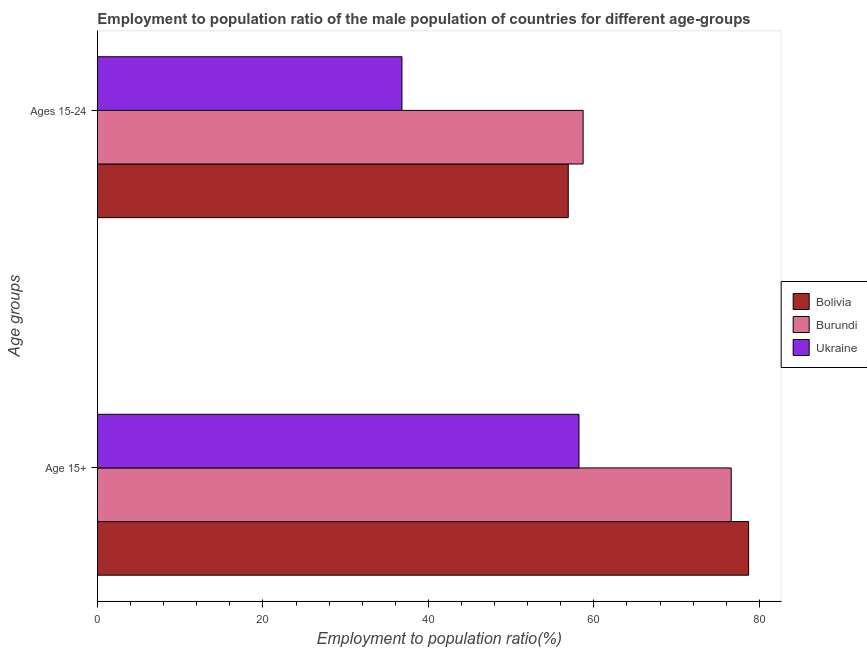How many different coloured bars are there?
Make the answer very short. 3. Are the number of bars on each tick of the Y-axis equal?
Provide a short and direct response. Yes. How many bars are there on the 1st tick from the top?
Offer a terse response. 3. What is the label of the 1st group of bars from the top?
Offer a very short reply. Ages 15-24. What is the employment to population ratio(age 15+) in Ukraine?
Offer a terse response. 58.2. Across all countries, what is the maximum employment to population ratio(age 15-24)?
Provide a short and direct response. 58.7. Across all countries, what is the minimum employment to population ratio(age 15-24)?
Your answer should be very brief. 36.8. In which country was the employment to population ratio(age 15-24) maximum?
Give a very brief answer. Burundi. In which country was the employment to population ratio(age 15-24) minimum?
Ensure brevity in your answer.  Ukraine. What is the total employment to population ratio(age 15+) in the graph?
Provide a succinct answer. 213.5. What is the difference between the employment to population ratio(age 15-24) in Ukraine and that in Burundi?
Offer a terse response. -21.9. What is the difference between the employment to population ratio(age 15-24) in Burundi and the employment to population ratio(age 15+) in Ukraine?
Make the answer very short. 0.5. What is the average employment to population ratio(age 15+) per country?
Make the answer very short. 71.17. What is the difference between the employment to population ratio(age 15-24) and employment to population ratio(age 15+) in Burundi?
Offer a terse response. -17.9. What is the ratio of the employment to population ratio(age 15-24) in Burundi to that in Bolivia?
Your answer should be compact. 1.03. Is the employment to population ratio(age 15-24) in Burundi less than that in Ukraine?
Give a very brief answer. No. What does the 1st bar from the top in Age 15+ represents?
Make the answer very short. Ukraine. What does the 2nd bar from the bottom in Age 15+ represents?
Ensure brevity in your answer.  Burundi. How many bars are there?
Offer a very short reply. 6. Are all the bars in the graph horizontal?
Make the answer very short. Yes. How many countries are there in the graph?
Give a very brief answer. 3. What is the difference between two consecutive major ticks on the X-axis?
Keep it short and to the point. 20. How many legend labels are there?
Provide a succinct answer. 3. How are the legend labels stacked?
Keep it short and to the point. Vertical. What is the title of the graph?
Keep it short and to the point. Employment to population ratio of the male population of countries for different age-groups. Does "Mauritius" appear as one of the legend labels in the graph?
Your answer should be compact. No. What is the label or title of the X-axis?
Keep it short and to the point. Employment to population ratio(%). What is the label or title of the Y-axis?
Offer a terse response. Age groups. What is the Employment to population ratio(%) of Bolivia in Age 15+?
Keep it short and to the point. 78.7. What is the Employment to population ratio(%) in Burundi in Age 15+?
Your answer should be very brief. 76.6. What is the Employment to population ratio(%) of Ukraine in Age 15+?
Ensure brevity in your answer.  58.2. What is the Employment to population ratio(%) in Bolivia in Ages 15-24?
Offer a very short reply. 56.9. What is the Employment to population ratio(%) in Burundi in Ages 15-24?
Offer a very short reply. 58.7. What is the Employment to population ratio(%) in Ukraine in Ages 15-24?
Your answer should be compact. 36.8. Across all Age groups, what is the maximum Employment to population ratio(%) in Bolivia?
Give a very brief answer. 78.7. Across all Age groups, what is the maximum Employment to population ratio(%) in Burundi?
Ensure brevity in your answer.  76.6. Across all Age groups, what is the maximum Employment to population ratio(%) in Ukraine?
Make the answer very short. 58.2. Across all Age groups, what is the minimum Employment to population ratio(%) of Bolivia?
Make the answer very short. 56.9. Across all Age groups, what is the minimum Employment to population ratio(%) in Burundi?
Provide a short and direct response. 58.7. Across all Age groups, what is the minimum Employment to population ratio(%) in Ukraine?
Offer a very short reply. 36.8. What is the total Employment to population ratio(%) of Bolivia in the graph?
Your response must be concise. 135.6. What is the total Employment to population ratio(%) in Burundi in the graph?
Provide a succinct answer. 135.3. What is the difference between the Employment to population ratio(%) of Bolivia in Age 15+ and that in Ages 15-24?
Give a very brief answer. 21.8. What is the difference between the Employment to population ratio(%) of Burundi in Age 15+ and that in Ages 15-24?
Provide a succinct answer. 17.9. What is the difference between the Employment to population ratio(%) in Ukraine in Age 15+ and that in Ages 15-24?
Keep it short and to the point. 21.4. What is the difference between the Employment to population ratio(%) in Bolivia in Age 15+ and the Employment to population ratio(%) in Ukraine in Ages 15-24?
Provide a short and direct response. 41.9. What is the difference between the Employment to population ratio(%) in Burundi in Age 15+ and the Employment to population ratio(%) in Ukraine in Ages 15-24?
Provide a short and direct response. 39.8. What is the average Employment to population ratio(%) of Bolivia per Age groups?
Provide a short and direct response. 67.8. What is the average Employment to population ratio(%) of Burundi per Age groups?
Provide a succinct answer. 67.65. What is the average Employment to population ratio(%) of Ukraine per Age groups?
Make the answer very short. 47.5. What is the difference between the Employment to population ratio(%) in Burundi and Employment to population ratio(%) in Ukraine in Age 15+?
Make the answer very short. 18.4. What is the difference between the Employment to population ratio(%) in Bolivia and Employment to population ratio(%) in Ukraine in Ages 15-24?
Provide a short and direct response. 20.1. What is the difference between the Employment to population ratio(%) in Burundi and Employment to population ratio(%) in Ukraine in Ages 15-24?
Your answer should be very brief. 21.9. What is the ratio of the Employment to population ratio(%) of Bolivia in Age 15+ to that in Ages 15-24?
Offer a very short reply. 1.38. What is the ratio of the Employment to population ratio(%) in Burundi in Age 15+ to that in Ages 15-24?
Provide a succinct answer. 1.3. What is the ratio of the Employment to population ratio(%) in Ukraine in Age 15+ to that in Ages 15-24?
Ensure brevity in your answer.  1.58. What is the difference between the highest and the second highest Employment to population ratio(%) of Bolivia?
Offer a very short reply. 21.8. What is the difference between the highest and the second highest Employment to population ratio(%) of Ukraine?
Make the answer very short. 21.4. What is the difference between the highest and the lowest Employment to population ratio(%) in Bolivia?
Keep it short and to the point. 21.8. What is the difference between the highest and the lowest Employment to population ratio(%) of Burundi?
Keep it short and to the point. 17.9. What is the difference between the highest and the lowest Employment to population ratio(%) of Ukraine?
Your answer should be compact. 21.4. 